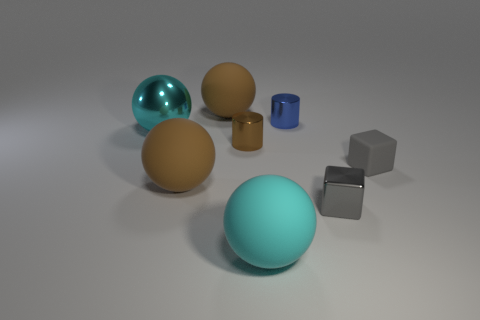Add 1 large objects. How many objects exist? 9 Subtract all cylinders. How many objects are left? 6 Subtract all matte spheres. Subtract all blue cylinders. How many objects are left? 4 Add 2 small brown metallic things. How many small brown metallic things are left? 3 Add 7 shiny blocks. How many shiny blocks exist? 8 Subtract 0 gray balls. How many objects are left? 8 